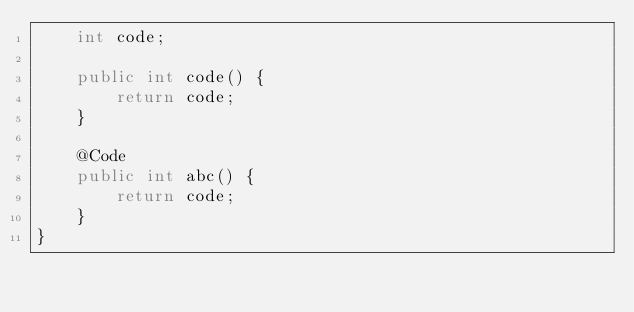Convert code to text. <code><loc_0><loc_0><loc_500><loc_500><_Java_>    int code;

    public int code() {
        return code;
    }

    @Code
    public int abc() {
        return code;
    }
}
</code> 